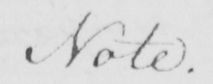Please provide the text content of this handwritten line. Note . 